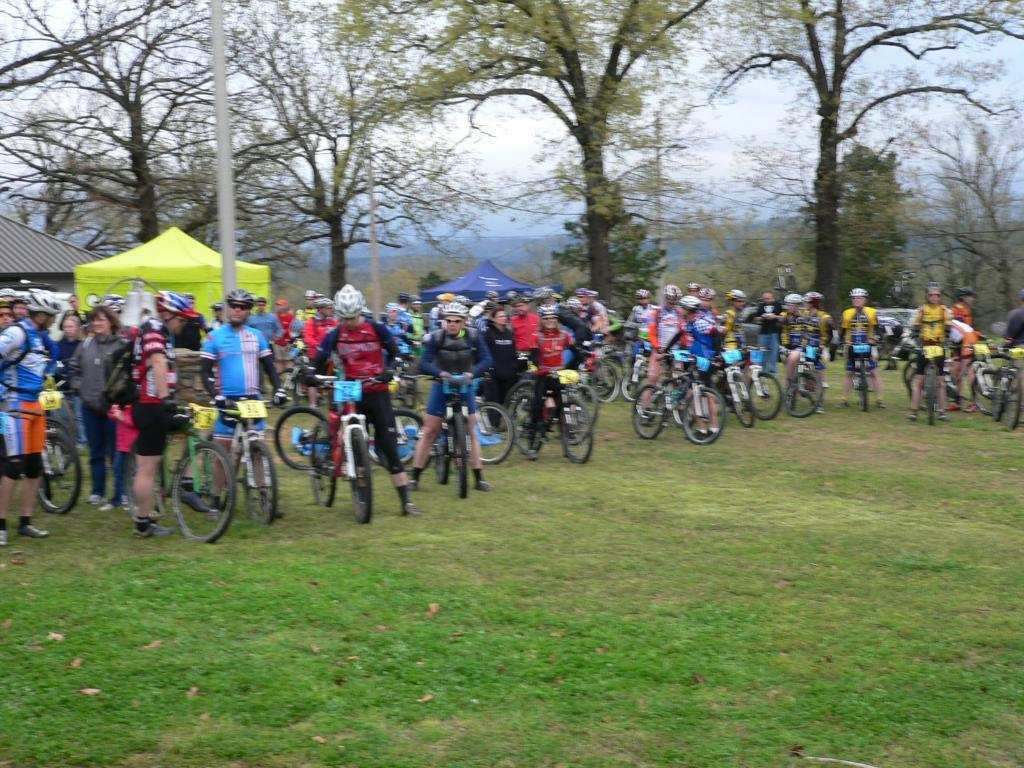How many people are present in the image? There are many people in the image. What are the people doing in the image? The people are standing along with cycles. What type of surface are they standing on? The surface they are standing on is grass. What can be seen in the background of the image? There are trees visible in the background of the image. What type of cent can be seen flying in the image? There is no cent present in the image, and therefore no such activity can be observed. 